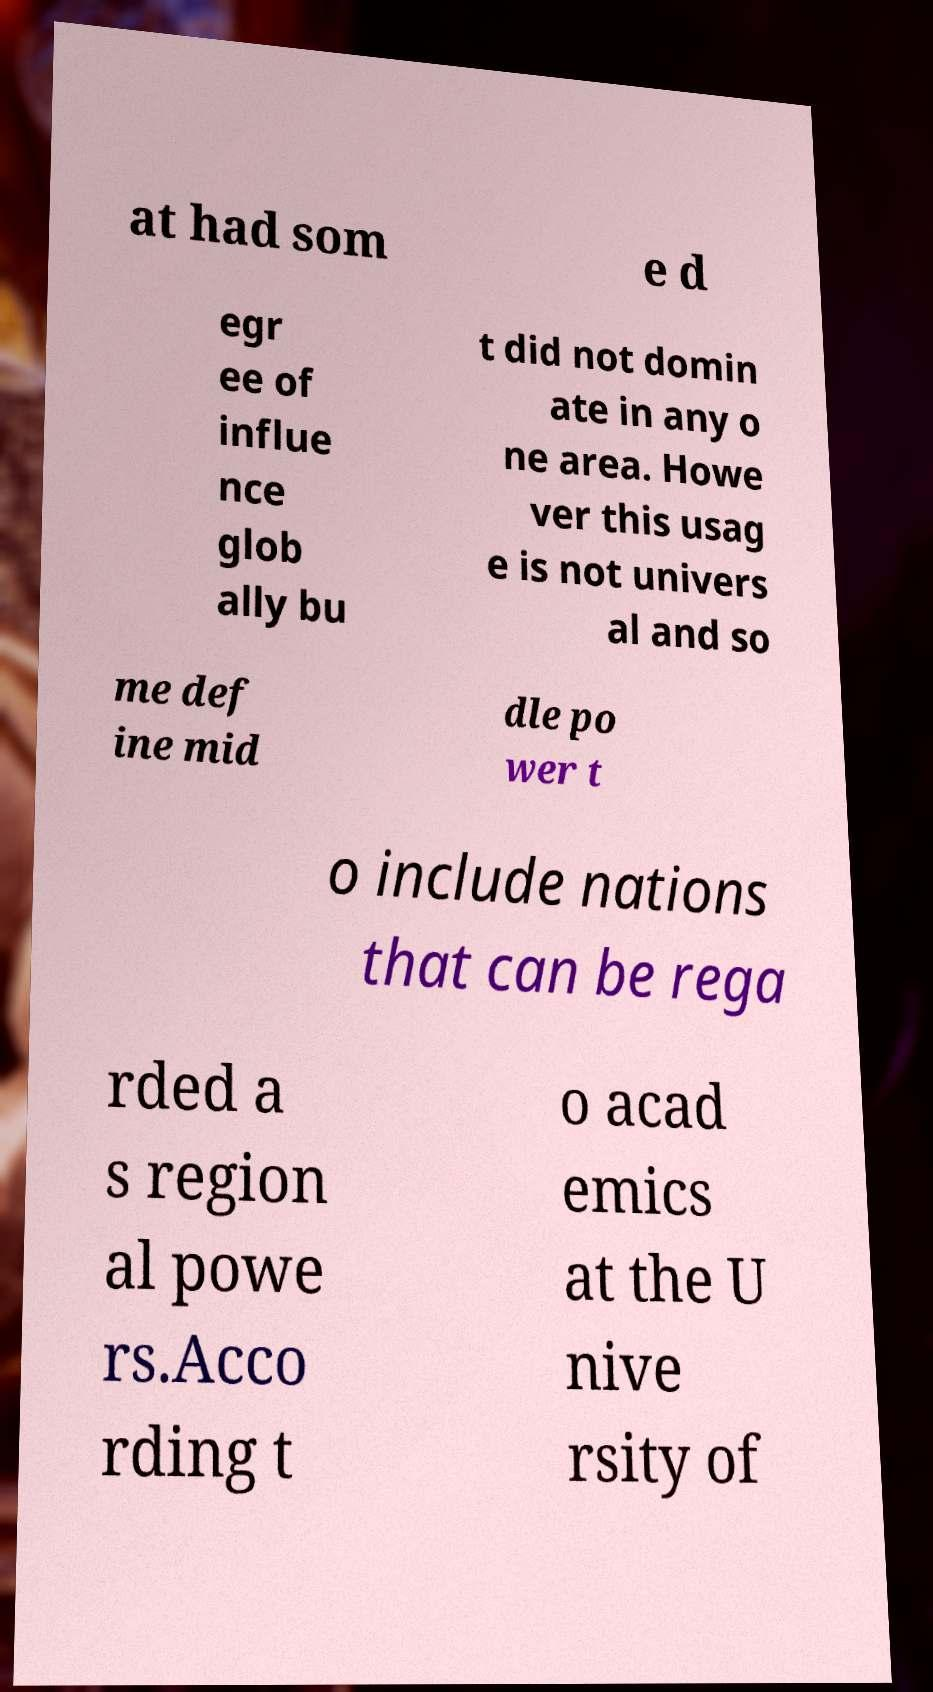I need the written content from this picture converted into text. Can you do that? at had som e d egr ee of influe nce glob ally bu t did not domin ate in any o ne area. Howe ver this usag e is not univers al and so me def ine mid dle po wer t o include nations that can be rega rded a s region al powe rs.Acco rding t o acad emics at the U nive rsity of 